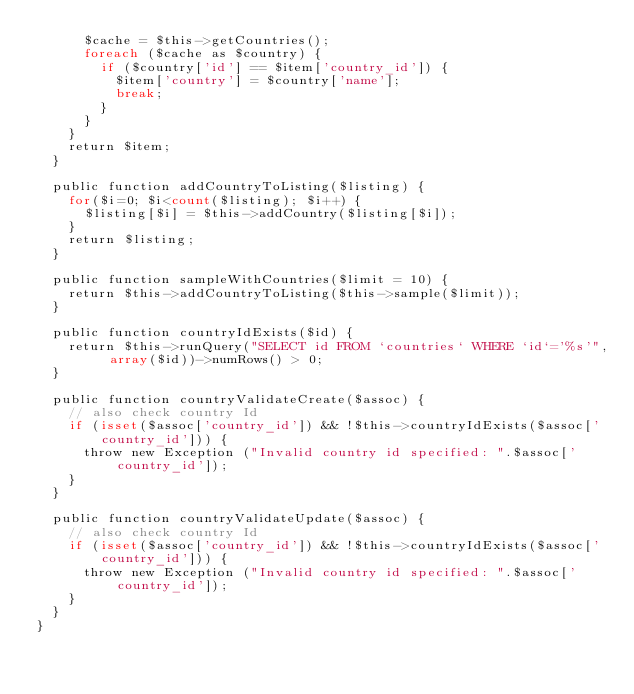<code> <loc_0><loc_0><loc_500><loc_500><_PHP_>      $cache = $this->getCountries();
      foreach ($cache as $country) {
        if ($country['id'] == $item['country_id']) {
          $item['country'] = $country['name'];
          break;
        }
      }
    }
    return $item;
  }
  
  public function addCountryToListing($listing) {
    for($i=0; $i<count($listing); $i++) {
      $listing[$i] = $this->addCountry($listing[$i]);
    }
    return $listing;
  }
  
  public function sampleWithCountries($limit = 10) {
    return $this->addCountryToListing($this->sample($limit));
  }
  
  public function countryIdExists($id) {
    return $this->runQuery("SELECT id FROM `countries` WHERE `id`='%s'", array($id))->numRows() > 0;
  }
  
  public function countryValidateCreate($assoc) {
    // also check country Id
    if (isset($assoc['country_id']) && !$this->countryIdExists($assoc['country_id'])) {
      throw new Exception ("Invalid country id specified: ".$assoc['country_id']);
    }
  }

  public function countryValidateUpdate($assoc) {
    // also check country Id
    if (isset($assoc['country_id']) && !$this->countryIdExists($assoc['country_id'])) {
      throw new Exception ("Invalid country id specified: ".$assoc['country_id']);
    }
  }
}
</code> 